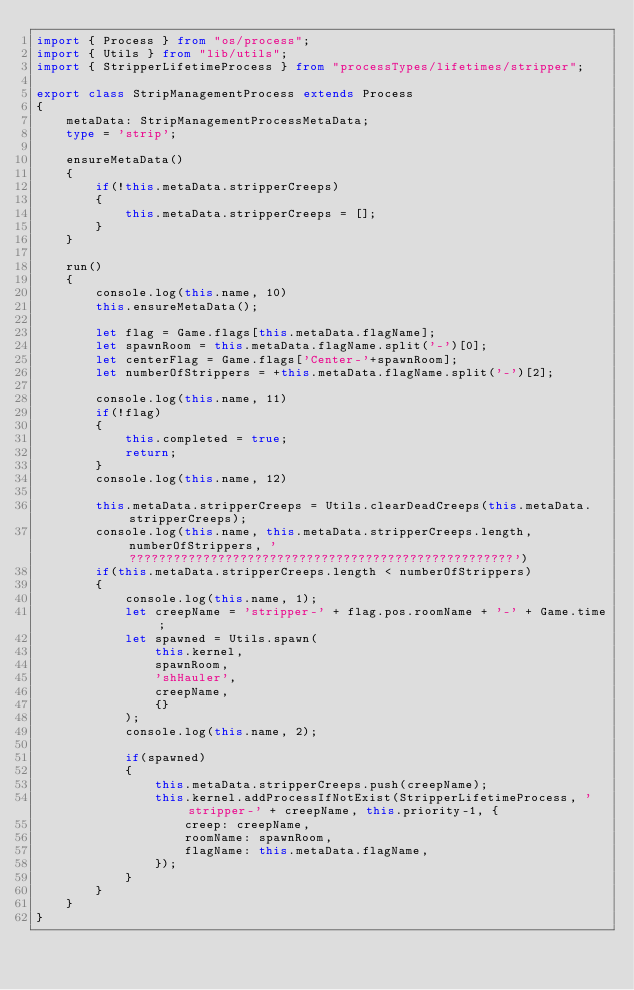<code> <loc_0><loc_0><loc_500><loc_500><_TypeScript_>import { Process } from "os/process";
import { Utils } from "lib/utils";
import { StripperLifetimeProcess } from "processTypes/lifetimes/stripper";

export class StripManagementProcess extends Process
{
    metaData: StripManagementProcessMetaData;
    type = 'strip';

    ensureMetaData()
    {
        if(!this.metaData.stripperCreeps)
        {
            this.metaData.stripperCreeps = [];
        }
    }

    run()
    {
        console.log(this.name, 10)
        this.ensureMetaData();

        let flag = Game.flags[this.metaData.flagName];
        let spawnRoom = this.metaData.flagName.split('-')[0];
        let centerFlag = Game.flags['Center-'+spawnRoom];
        let numberOfStrippers = +this.metaData.flagName.split('-')[2];

        console.log(this.name, 11)
        if(!flag)
        {
            this.completed = true;
            return;
        }
        console.log(this.name, 12)

        this.metaData.stripperCreeps = Utils.clearDeadCreeps(this.metaData.stripperCreeps);
        console.log(this.name, this.metaData.stripperCreeps.length, numberOfStrippers, '????????????????????????????????????????????????????')
        if(this.metaData.stripperCreeps.length < numberOfStrippers)
        {
            console.log(this.name, 1);
            let creepName = 'stripper-' + flag.pos.roomName + '-' + Game.time;
            let spawned = Utils.spawn(
                this.kernel,
                spawnRoom,
                'shHauler',
                creepName,
                {}
            );
            console.log(this.name, 2);

            if(spawned)
            {
                this.metaData.stripperCreeps.push(creepName);
                this.kernel.addProcessIfNotExist(StripperLifetimeProcess, 'stripper-' + creepName, this.priority-1, {
                    creep: creepName,
                    roomName: spawnRoom,
                    flagName: this.metaData.flagName,
                });
            }
        }
    }
}
</code> 